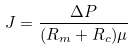<formula> <loc_0><loc_0><loc_500><loc_500>J = \frac { \Delta P } { ( R _ { m } + R _ { c } ) \mu }</formula> 